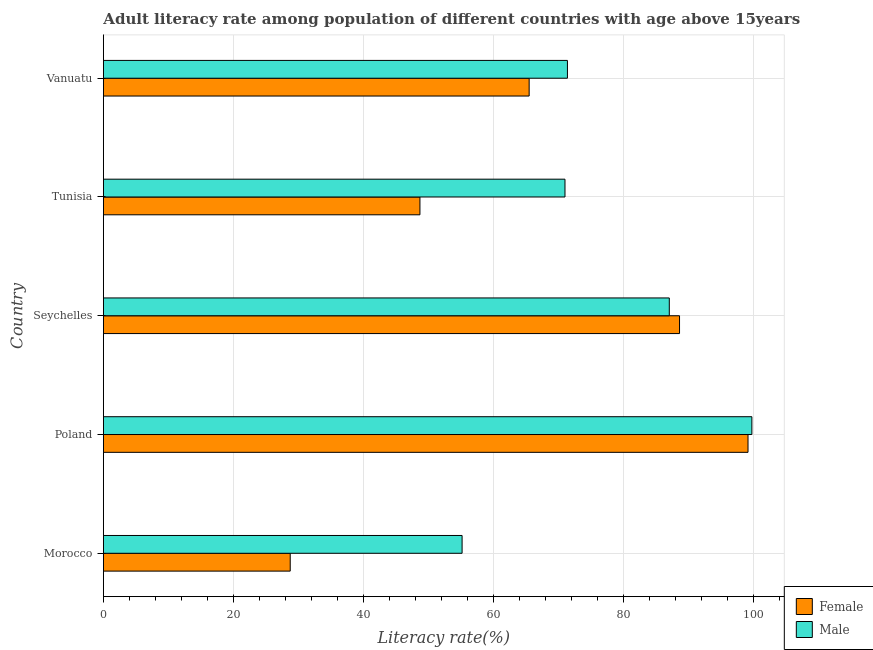How many groups of bars are there?
Provide a succinct answer. 5. What is the label of the 2nd group of bars from the top?
Ensure brevity in your answer.  Tunisia. In how many cases, is the number of bars for a given country not equal to the number of legend labels?
Provide a short and direct response. 0. What is the female adult literacy rate in Morocco?
Keep it short and to the point. 28.73. Across all countries, what is the maximum male adult literacy rate?
Ensure brevity in your answer.  99.71. Across all countries, what is the minimum female adult literacy rate?
Ensure brevity in your answer.  28.73. In which country was the male adult literacy rate minimum?
Ensure brevity in your answer.  Morocco. What is the total male adult literacy rate in the graph?
Provide a short and direct response. 384.21. What is the difference between the male adult literacy rate in Morocco and that in Seychelles?
Your answer should be very brief. -31.86. What is the difference between the female adult literacy rate in Seychelles and the male adult literacy rate in Vanuatu?
Offer a very short reply. 17.24. What is the average female adult literacy rate per country?
Provide a short and direct response. 66.11. What is the difference between the male adult literacy rate and female adult literacy rate in Vanuatu?
Your response must be concise. 5.88. In how many countries, is the female adult literacy rate greater than 56 %?
Your response must be concise. 3. What is the ratio of the male adult literacy rate in Seychelles to that in Vanuatu?
Make the answer very short. 1.22. What is the difference between the highest and the second highest male adult literacy rate?
Keep it short and to the point. 12.7. What is the difference between the highest and the lowest male adult literacy rate?
Provide a succinct answer. 44.56. In how many countries, is the male adult literacy rate greater than the average male adult literacy rate taken over all countries?
Offer a terse response. 2. Is the sum of the male adult literacy rate in Poland and Vanuatu greater than the maximum female adult literacy rate across all countries?
Your response must be concise. Yes. What does the 2nd bar from the top in Poland represents?
Offer a terse response. Female. Are all the bars in the graph horizontal?
Keep it short and to the point. Yes. Does the graph contain grids?
Your answer should be compact. Yes. How are the legend labels stacked?
Your answer should be very brief. Vertical. What is the title of the graph?
Ensure brevity in your answer.  Adult literacy rate among population of different countries with age above 15years. Does "Official creditors" appear as one of the legend labels in the graph?
Offer a very short reply. No. What is the label or title of the X-axis?
Keep it short and to the point. Literacy rate(%). What is the label or title of the Y-axis?
Provide a short and direct response. Country. What is the Literacy rate(%) of Female in Morocco?
Give a very brief answer. 28.73. What is the Literacy rate(%) of Male in Morocco?
Your answer should be compact. 55.16. What is the Literacy rate(%) in Female in Poland?
Your response must be concise. 99.12. What is the Literacy rate(%) of Male in Poland?
Offer a very short reply. 99.71. What is the Literacy rate(%) of Female in Seychelles?
Your response must be concise. 88.59. What is the Literacy rate(%) in Male in Seychelles?
Your answer should be compact. 87.02. What is the Literacy rate(%) of Female in Tunisia?
Offer a terse response. 48.67. What is the Literacy rate(%) of Male in Tunisia?
Provide a short and direct response. 70.97. What is the Literacy rate(%) of Female in Vanuatu?
Make the answer very short. 65.47. What is the Literacy rate(%) of Male in Vanuatu?
Provide a short and direct response. 71.35. Across all countries, what is the maximum Literacy rate(%) in Female?
Your answer should be compact. 99.12. Across all countries, what is the maximum Literacy rate(%) in Male?
Ensure brevity in your answer.  99.71. Across all countries, what is the minimum Literacy rate(%) of Female?
Your response must be concise. 28.73. Across all countries, what is the minimum Literacy rate(%) of Male?
Your answer should be very brief. 55.16. What is the total Literacy rate(%) in Female in the graph?
Ensure brevity in your answer.  330.57. What is the total Literacy rate(%) of Male in the graph?
Give a very brief answer. 384.21. What is the difference between the Literacy rate(%) of Female in Morocco and that in Poland?
Keep it short and to the point. -70.39. What is the difference between the Literacy rate(%) of Male in Morocco and that in Poland?
Keep it short and to the point. -44.56. What is the difference between the Literacy rate(%) of Female in Morocco and that in Seychelles?
Offer a terse response. -59.86. What is the difference between the Literacy rate(%) in Male in Morocco and that in Seychelles?
Your response must be concise. -31.86. What is the difference between the Literacy rate(%) in Female in Morocco and that in Tunisia?
Make the answer very short. -19.95. What is the difference between the Literacy rate(%) of Male in Morocco and that in Tunisia?
Give a very brief answer. -15.82. What is the difference between the Literacy rate(%) of Female in Morocco and that in Vanuatu?
Give a very brief answer. -36.74. What is the difference between the Literacy rate(%) of Male in Morocco and that in Vanuatu?
Offer a terse response. -16.2. What is the difference between the Literacy rate(%) in Female in Poland and that in Seychelles?
Make the answer very short. 10.53. What is the difference between the Literacy rate(%) of Male in Poland and that in Seychelles?
Your answer should be very brief. 12.7. What is the difference between the Literacy rate(%) in Female in Poland and that in Tunisia?
Make the answer very short. 50.45. What is the difference between the Literacy rate(%) of Male in Poland and that in Tunisia?
Make the answer very short. 28.74. What is the difference between the Literacy rate(%) of Female in Poland and that in Vanuatu?
Your answer should be very brief. 33.65. What is the difference between the Literacy rate(%) of Male in Poland and that in Vanuatu?
Offer a terse response. 28.36. What is the difference between the Literacy rate(%) of Female in Seychelles and that in Tunisia?
Your answer should be compact. 39.91. What is the difference between the Literacy rate(%) of Male in Seychelles and that in Tunisia?
Your answer should be compact. 16.04. What is the difference between the Literacy rate(%) in Female in Seychelles and that in Vanuatu?
Provide a short and direct response. 23.12. What is the difference between the Literacy rate(%) of Male in Seychelles and that in Vanuatu?
Offer a very short reply. 15.66. What is the difference between the Literacy rate(%) of Female in Tunisia and that in Vanuatu?
Your response must be concise. -16.79. What is the difference between the Literacy rate(%) in Male in Tunisia and that in Vanuatu?
Your response must be concise. -0.38. What is the difference between the Literacy rate(%) in Female in Morocco and the Literacy rate(%) in Male in Poland?
Give a very brief answer. -70.99. What is the difference between the Literacy rate(%) in Female in Morocco and the Literacy rate(%) in Male in Seychelles?
Provide a short and direct response. -58.29. What is the difference between the Literacy rate(%) in Female in Morocco and the Literacy rate(%) in Male in Tunisia?
Your answer should be compact. -42.25. What is the difference between the Literacy rate(%) of Female in Morocco and the Literacy rate(%) of Male in Vanuatu?
Ensure brevity in your answer.  -42.63. What is the difference between the Literacy rate(%) of Female in Poland and the Literacy rate(%) of Male in Seychelles?
Your answer should be compact. 12.1. What is the difference between the Literacy rate(%) in Female in Poland and the Literacy rate(%) in Male in Tunisia?
Your answer should be compact. 28.14. What is the difference between the Literacy rate(%) in Female in Poland and the Literacy rate(%) in Male in Vanuatu?
Offer a very short reply. 27.77. What is the difference between the Literacy rate(%) in Female in Seychelles and the Literacy rate(%) in Male in Tunisia?
Offer a terse response. 17.61. What is the difference between the Literacy rate(%) in Female in Seychelles and the Literacy rate(%) in Male in Vanuatu?
Keep it short and to the point. 17.24. What is the difference between the Literacy rate(%) of Female in Tunisia and the Literacy rate(%) of Male in Vanuatu?
Provide a succinct answer. -22.68. What is the average Literacy rate(%) of Female per country?
Make the answer very short. 66.11. What is the average Literacy rate(%) in Male per country?
Keep it short and to the point. 76.84. What is the difference between the Literacy rate(%) of Female and Literacy rate(%) of Male in Morocco?
Provide a short and direct response. -26.43. What is the difference between the Literacy rate(%) in Female and Literacy rate(%) in Male in Poland?
Give a very brief answer. -0.59. What is the difference between the Literacy rate(%) in Female and Literacy rate(%) in Male in Seychelles?
Offer a very short reply. 1.57. What is the difference between the Literacy rate(%) in Female and Literacy rate(%) in Male in Tunisia?
Keep it short and to the point. -22.3. What is the difference between the Literacy rate(%) of Female and Literacy rate(%) of Male in Vanuatu?
Keep it short and to the point. -5.88. What is the ratio of the Literacy rate(%) in Female in Morocco to that in Poland?
Your answer should be compact. 0.29. What is the ratio of the Literacy rate(%) in Male in Morocco to that in Poland?
Give a very brief answer. 0.55. What is the ratio of the Literacy rate(%) of Female in Morocco to that in Seychelles?
Your answer should be very brief. 0.32. What is the ratio of the Literacy rate(%) in Male in Morocco to that in Seychelles?
Provide a succinct answer. 0.63. What is the ratio of the Literacy rate(%) of Female in Morocco to that in Tunisia?
Your answer should be compact. 0.59. What is the ratio of the Literacy rate(%) in Male in Morocco to that in Tunisia?
Offer a terse response. 0.78. What is the ratio of the Literacy rate(%) in Female in Morocco to that in Vanuatu?
Provide a short and direct response. 0.44. What is the ratio of the Literacy rate(%) of Male in Morocco to that in Vanuatu?
Keep it short and to the point. 0.77. What is the ratio of the Literacy rate(%) in Female in Poland to that in Seychelles?
Your response must be concise. 1.12. What is the ratio of the Literacy rate(%) of Male in Poland to that in Seychelles?
Make the answer very short. 1.15. What is the ratio of the Literacy rate(%) of Female in Poland to that in Tunisia?
Provide a short and direct response. 2.04. What is the ratio of the Literacy rate(%) in Male in Poland to that in Tunisia?
Your answer should be compact. 1.4. What is the ratio of the Literacy rate(%) in Female in Poland to that in Vanuatu?
Provide a short and direct response. 1.51. What is the ratio of the Literacy rate(%) of Male in Poland to that in Vanuatu?
Your answer should be compact. 1.4. What is the ratio of the Literacy rate(%) of Female in Seychelles to that in Tunisia?
Provide a succinct answer. 1.82. What is the ratio of the Literacy rate(%) of Male in Seychelles to that in Tunisia?
Ensure brevity in your answer.  1.23. What is the ratio of the Literacy rate(%) of Female in Seychelles to that in Vanuatu?
Ensure brevity in your answer.  1.35. What is the ratio of the Literacy rate(%) of Male in Seychelles to that in Vanuatu?
Keep it short and to the point. 1.22. What is the ratio of the Literacy rate(%) in Female in Tunisia to that in Vanuatu?
Your answer should be compact. 0.74. What is the ratio of the Literacy rate(%) in Male in Tunisia to that in Vanuatu?
Provide a short and direct response. 0.99. What is the difference between the highest and the second highest Literacy rate(%) of Female?
Keep it short and to the point. 10.53. What is the difference between the highest and the second highest Literacy rate(%) of Male?
Make the answer very short. 12.7. What is the difference between the highest and the lowest Literacy rate(%) of Female?
Offer a terse response. 70.39. What is the difference between the highest and the lowest Literacy rate(%) of Male?
Your answer should be very brief. 44.56. 